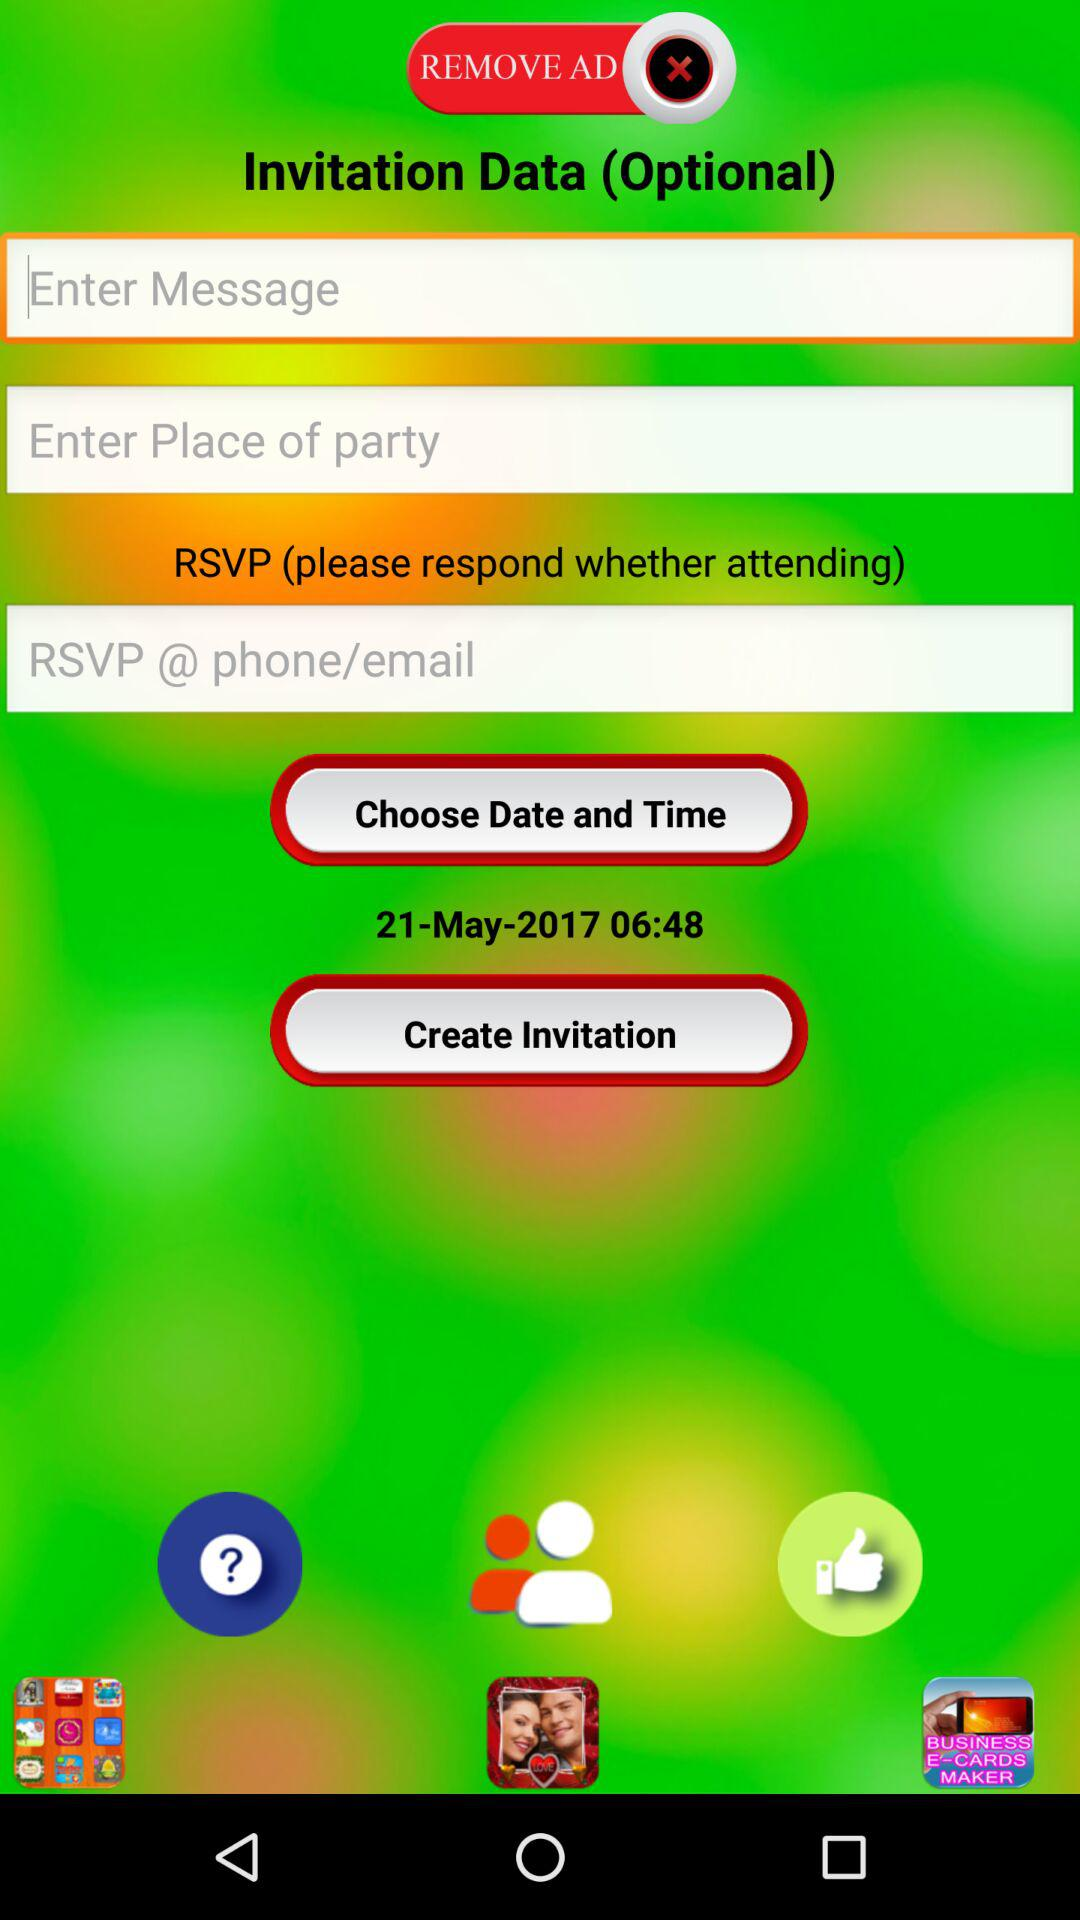What is the entered message?
When the provided information is insufficient, respond with <no answer>. <no answer> 